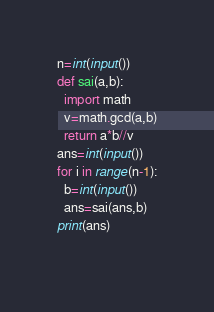Convert code to text. <code><loc_0><loc_0><loc_500><loc_500><_Python_>n=int(input())
def sai(a,b):
  import math
  v=math.gcd(a,b)
  return a*b//v
ans=int(input())
for i in range(n-1):
  b=int(input())
  ans=sai(ans,b)
print(ans)  
  </code> 